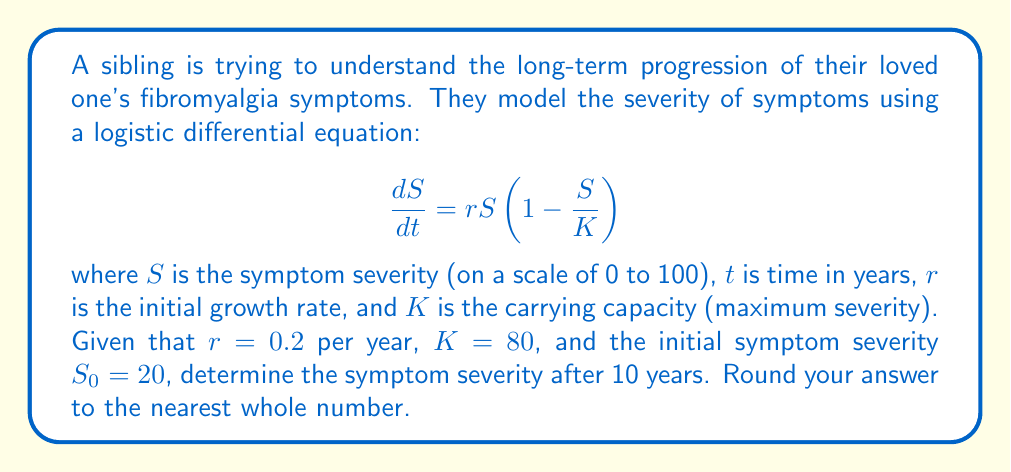Show me your answer to this math problem. To solve this problem, we need to use the solution to the logistic differential equation:

$$S(t) = \frac{K}{1 + (\frac{K}{S_0} - 1)e^{-rt}}$$

where $S(t)$ is the symptom severity at time $t$.

Let's plug in the given values:
$K = 80$
$S_0 = 20$
$r = 0.2$
$t = 10$

$$S(10) = \frac{80}{1 + (\frac{80}{20} - 1)e^{-0.2(10)}}$$

Simplify:
$$S(10) = \frac{80}{1 + (4 - 1)e^{-2}}$$
$$S(10) = \frac{80}{1 + 3e^{-2}}$$

Calculate $e^{-2}$:
$$e^{-2} \approx 0.1353$$

Substitute this value:
$$S(10) = \frac{80}{1 + 3(0.1353)}$$
$$S(10) = \frac{80}{1 + 0.4059}$$
$$S(10) = \frac{80}{1.4059}$$
$$S(10) \approx 56.9032$$

Rounding to the nearest whole number:
$$S(10) \approx 57$$
Answer: 57 